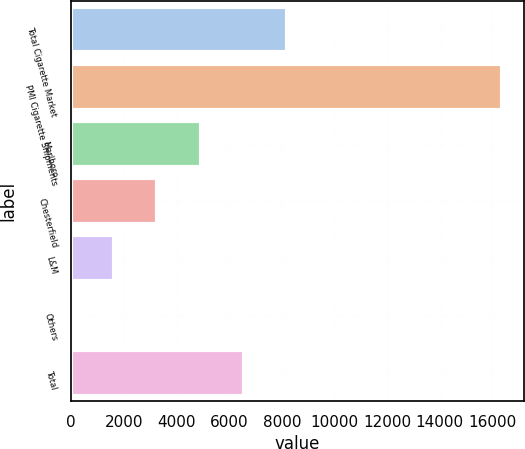Convert chart to OTSL. <chart><loc_0><loc_0><loc_500><loc_500><bar_chart><fcel>Total Cigarette Market<fcel>PMI Cigarette Shipments<fcel>Marlboro<fcel>Chesterfield<fcel>L&M<fcel>Others<fcel>Total<nl><fcel>8183.45<fcel>16365<fcel>4910.83<fcel>3274.52<fcel>1638.21<fcel>1.9<fcel>6547.14<nl></chart> 